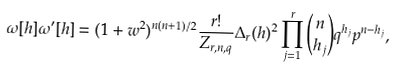Convert formula to latex. <formula><loc_0><loc_0><loc_500><loc_500>\omega [ h ] \omega ^ { \prime } [ h ] = ( 1 + w ^ { 2 } ) ^ { n ( n + 1 ) / 2 } \frac { r ! } { Z _ { r , n , q } } \Delta _ { r } ( h ) ^ { 2 } \prod _ { j = 1 } ^ { r } \binom { n } { h _ { j } } q ^ { h _ { j } } p ^ { n - h _ { j } } ,</formula> 